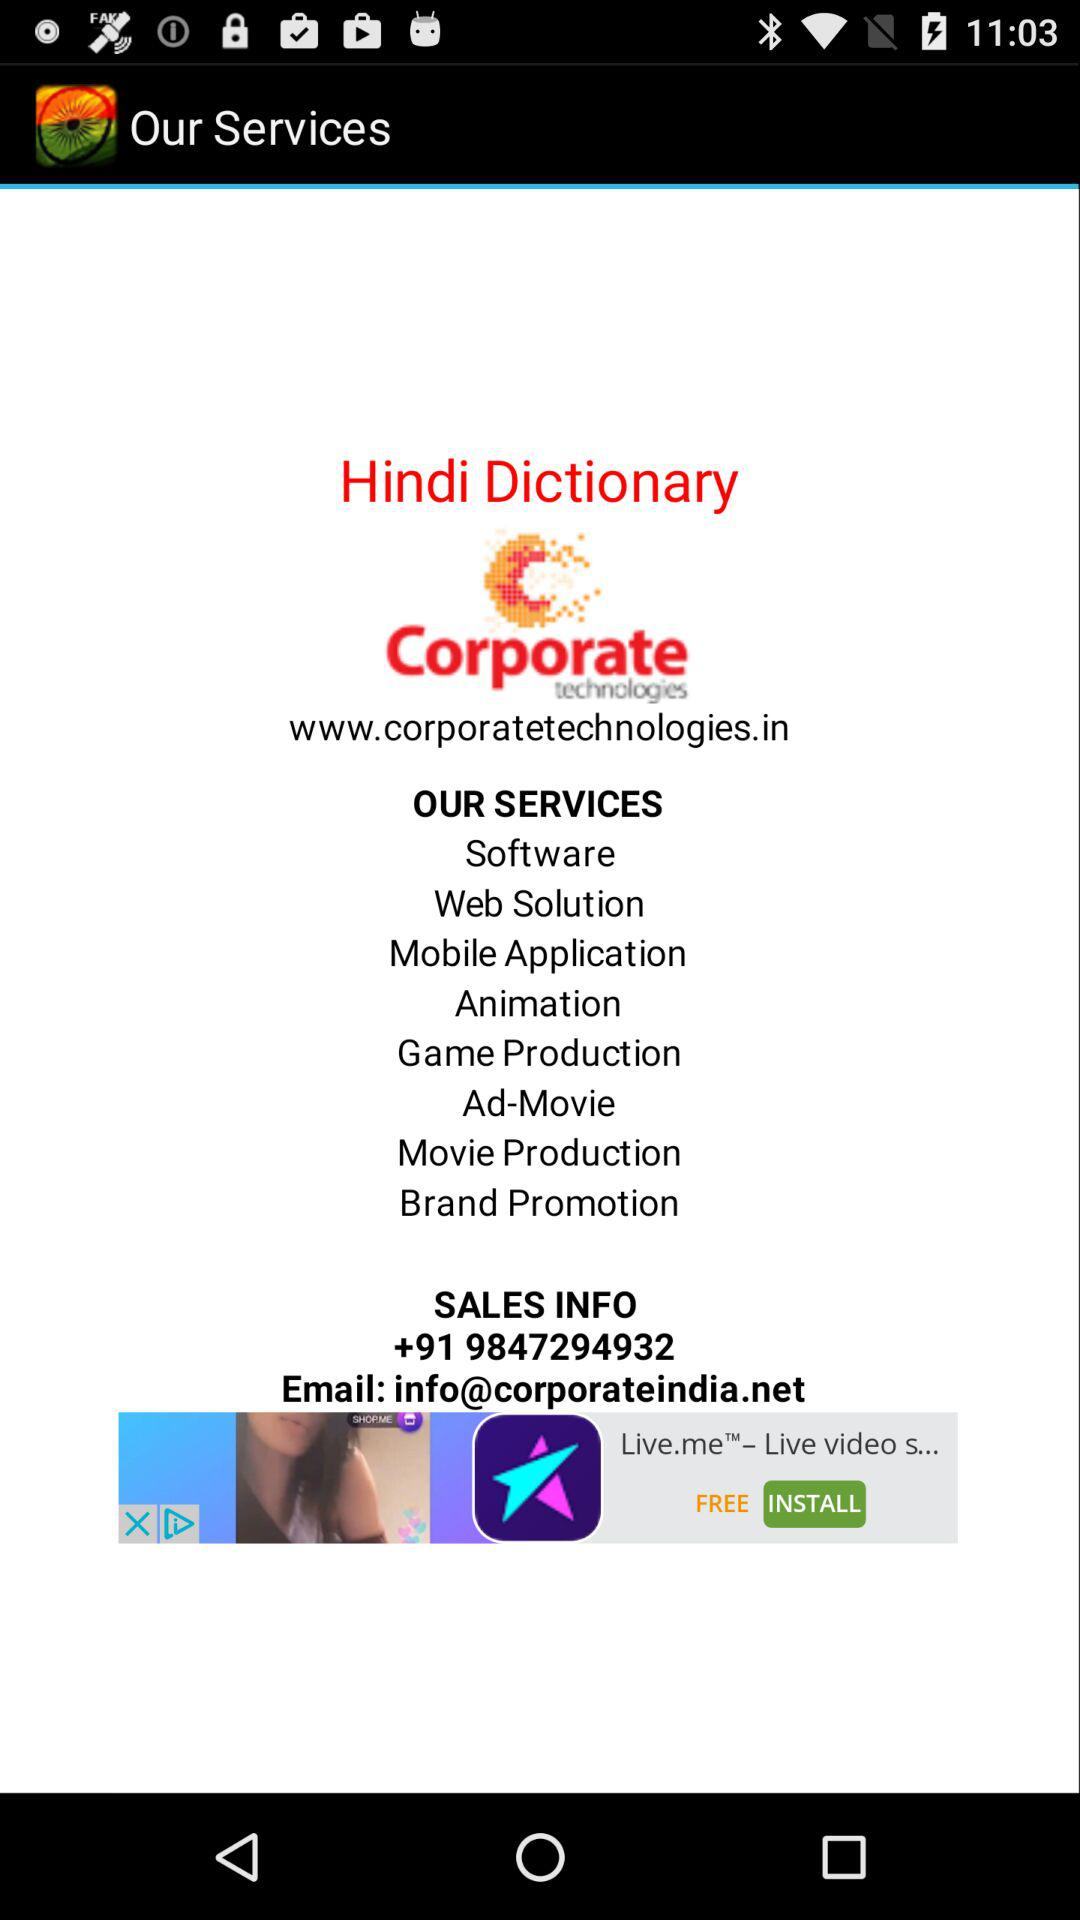In which city is the corporation located?
When the provided information is insufficient, respond with <no answer>. <no answer> 